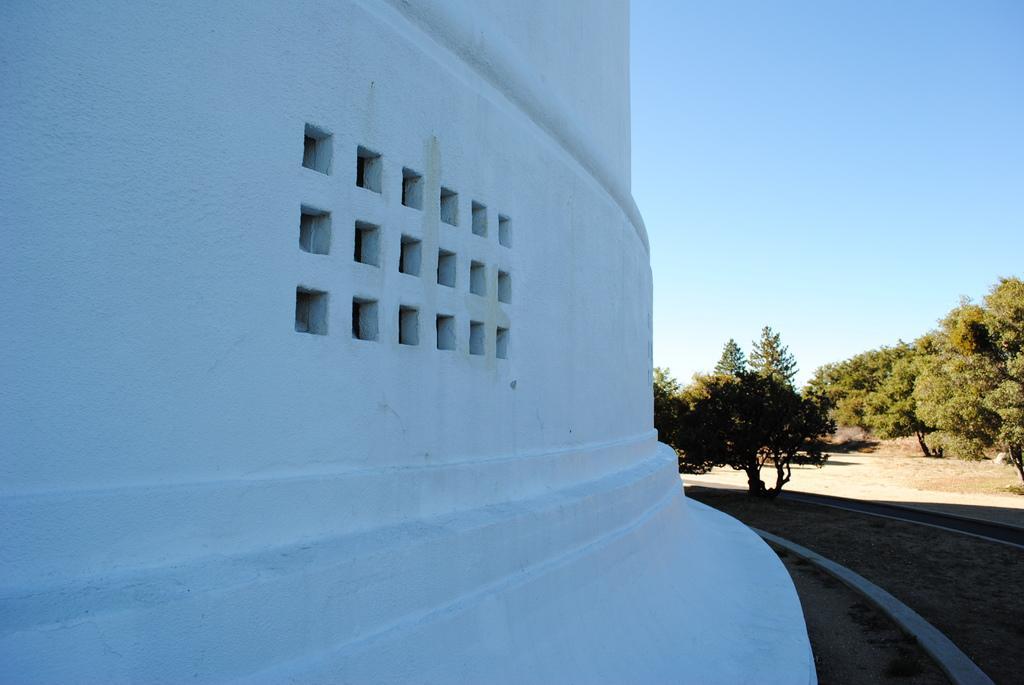In one or two sentences, can you explain what this image depicts? In this image, we can see a white wall. On the right side of the image, we can see trees, walkway, ground and sky. 